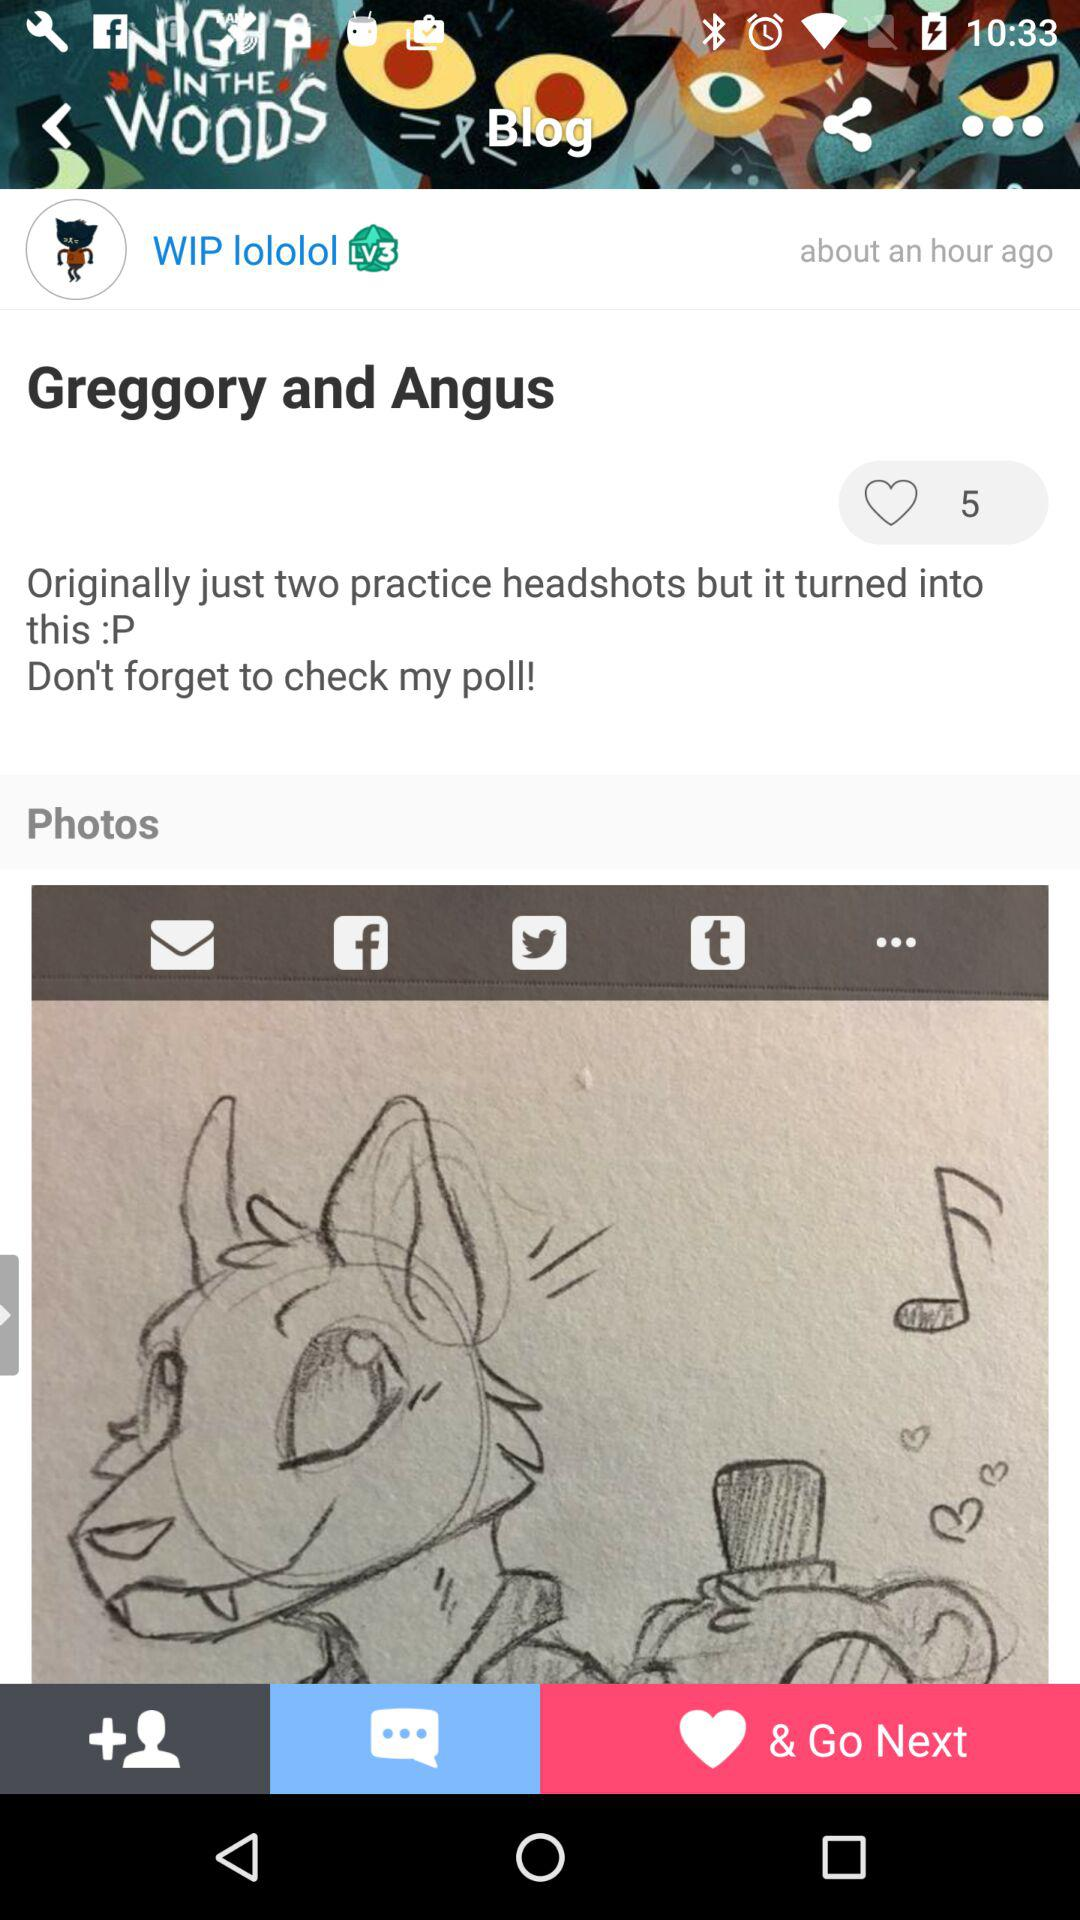How many hearts are on the post?
Answer the question using a single word or phrase. 5 